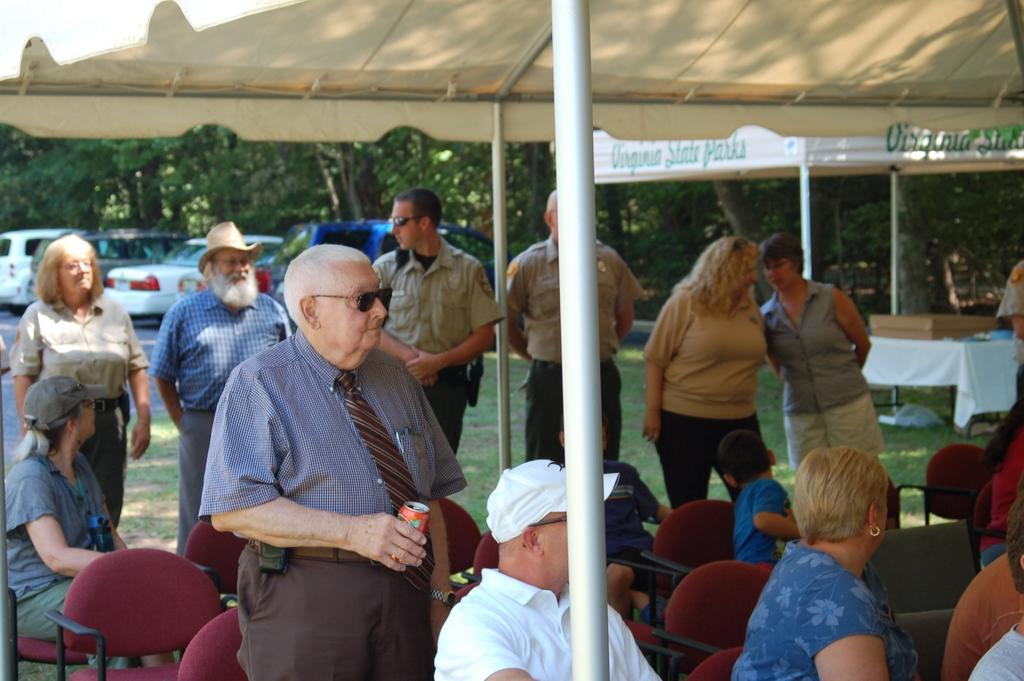How many people are in the image? There are persons in the image, but the exact number is not specified. What type of furniture is present in the image? There are chairs in the image. What type of temporary shelter is visible in the image? There are tents in the image. What type of vehicles are in the image? There are cars in the image. What type of vegetation is visible in the image? There are trees in the image. What type of fabric is covering the table in the image? There is a tablecloth in the image. What other objects can be seen in the image? There are some objects in the image, but their specific nature is not described. What is visible beneath the persons, chairs, tents, and cars in the image? The ground is visible in the image. How many hammers are being used to adjust the tents in the image? There is no mention of hammers or adjustments in the image; it only features persons, chairs, tents, cars, trees, a tablecloth, and some objects. 